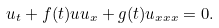Convert formula to latex. <formula><loc_0><loc_0><loc_500><loc_500>u _ { t } + f ( t ) u u _ { x } + g ( t ) u _ { x x x } = 0 .</formula> 